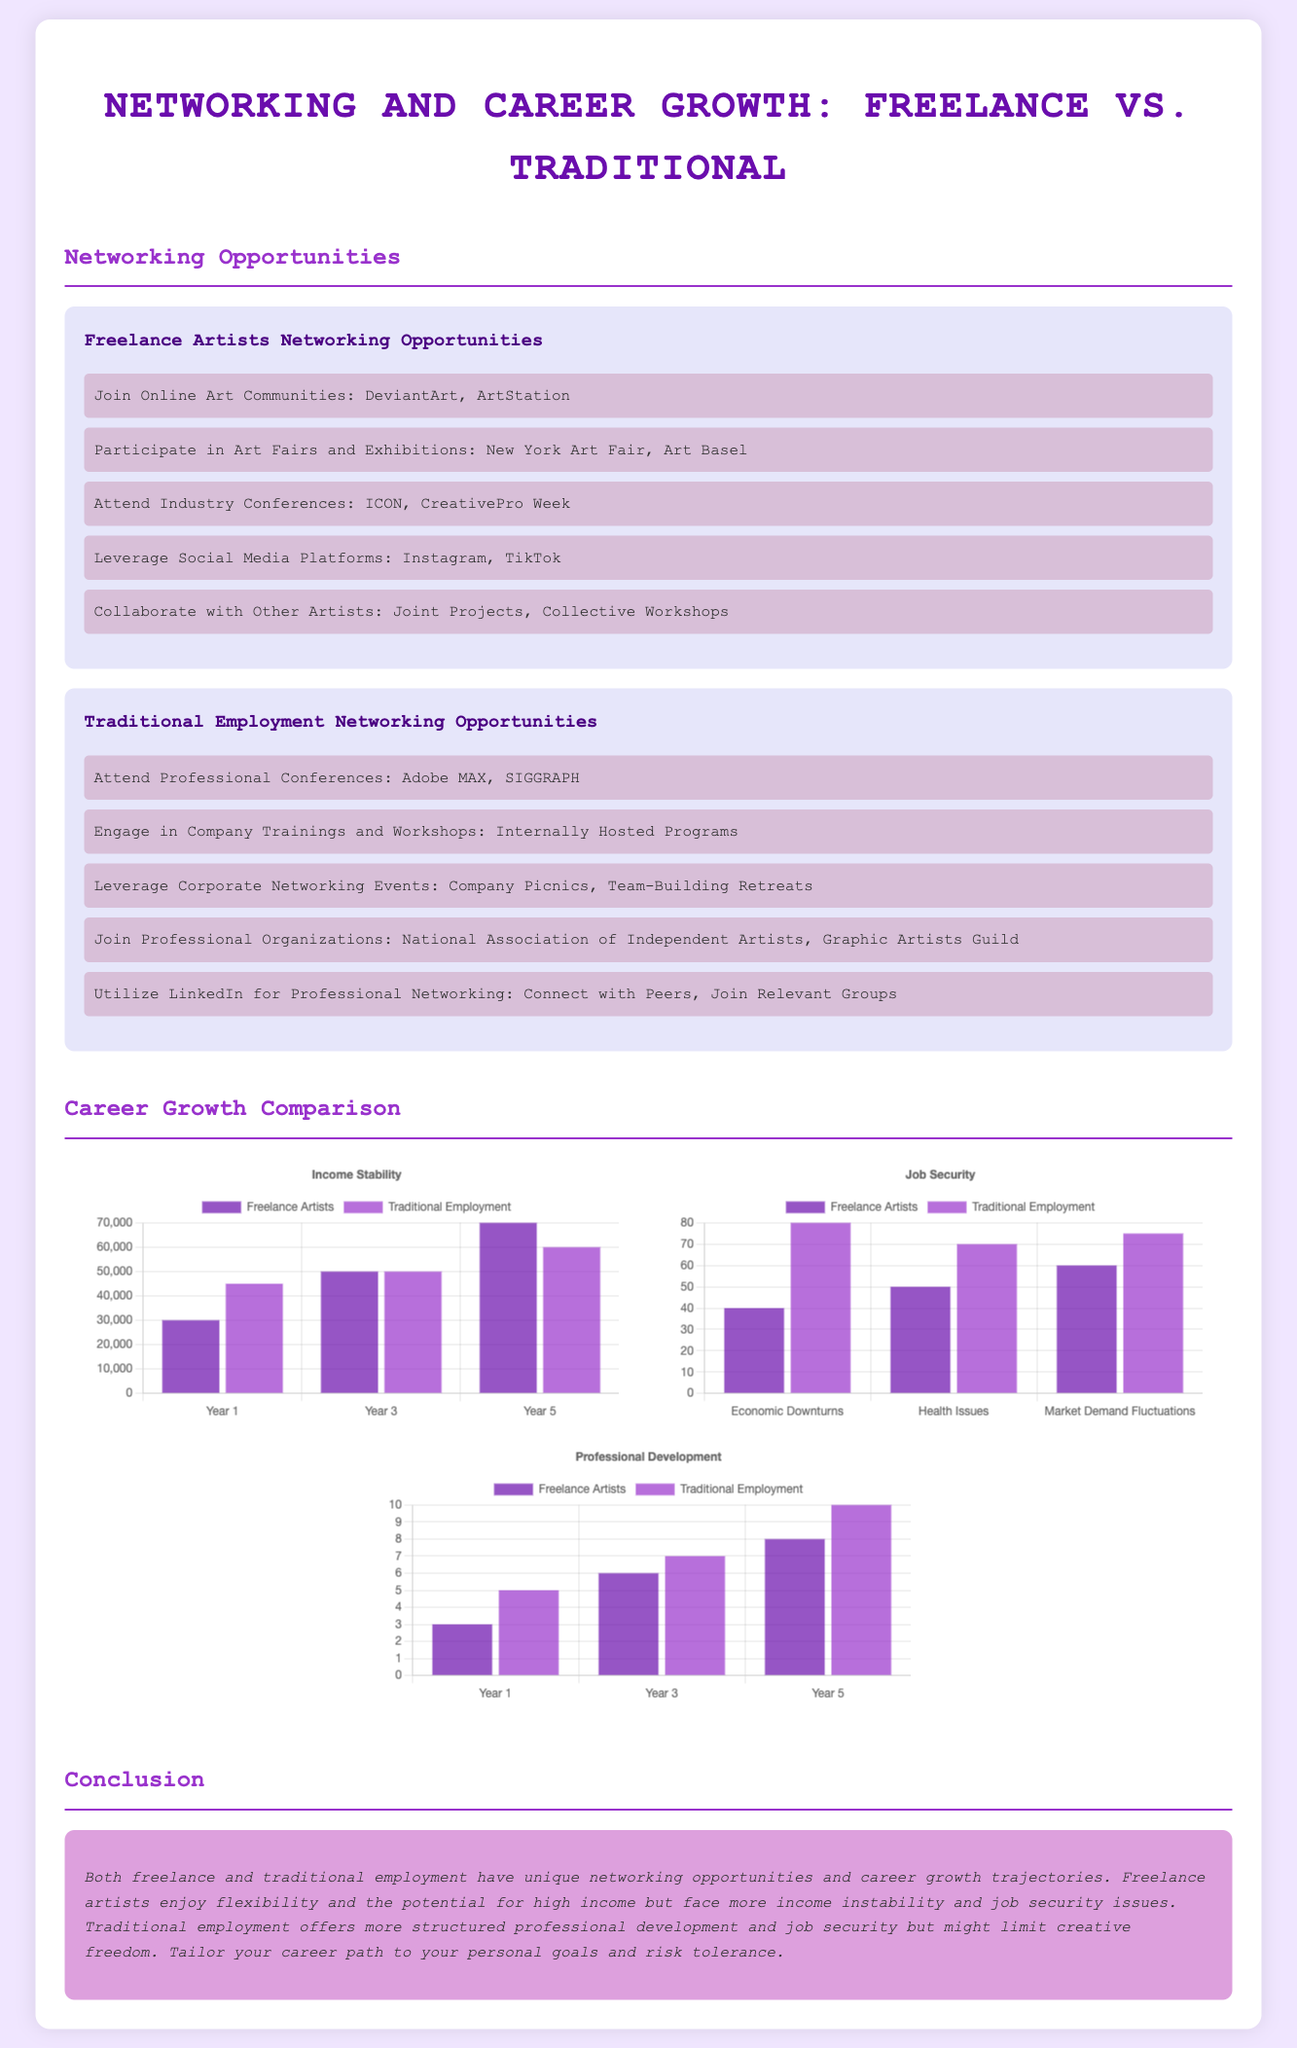what are the networking opportunities for freelance artists? The document lists several networking opportunities for freelance artists, including joining online art communities and participating in art fairs.
Answer: Join Online Art Communities: DeviantArt, ArtStation how many years does the income chart cover? The income stability chart shows data for three years: Year 1, Year 3, and Year 5.
Answer: 3 years what is the highest recorded job security percentage for traditional employment? The job security chart shows the maximum percentage recorded for traditional employment during economic downturns.
Answer: 80 how does professional development for freelance artists compare to traditional employment in Year 5? The professional development chart illustrates the difference between freelance artists and traditional employment for Year 5.
Answer: 8 vs 10 which type of employment has better job security against health issues? The job security chart indicates the percentage of job security for freelance artists and traditional employment specifically against health issues.
Answer: Traditional Employment what is the average income for freelance artists in Year 3? The income chart states the average income for freelance artists at Year 3, which is provided in the dataset.
Answer: 50000 which list mentions collaborating with other artists? The networking opportunities specifically for freelance artists includes collaborating with other artists as a networking opportunity.
Answer: Freelance Artists Networking Opportunities how much is the average income for traditional employment in Year 5? The income chart provides the average income for traditional employment at Year 5, according to the data shown.
Answer: 60000 